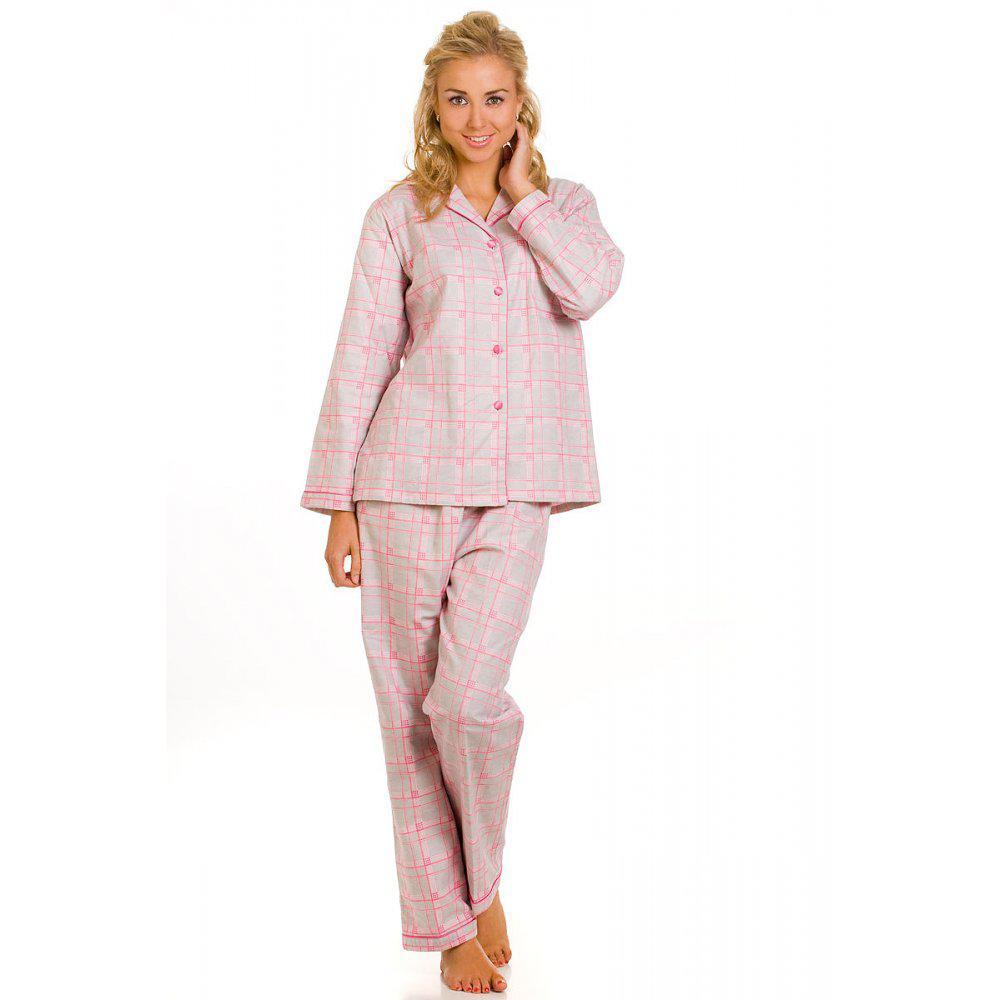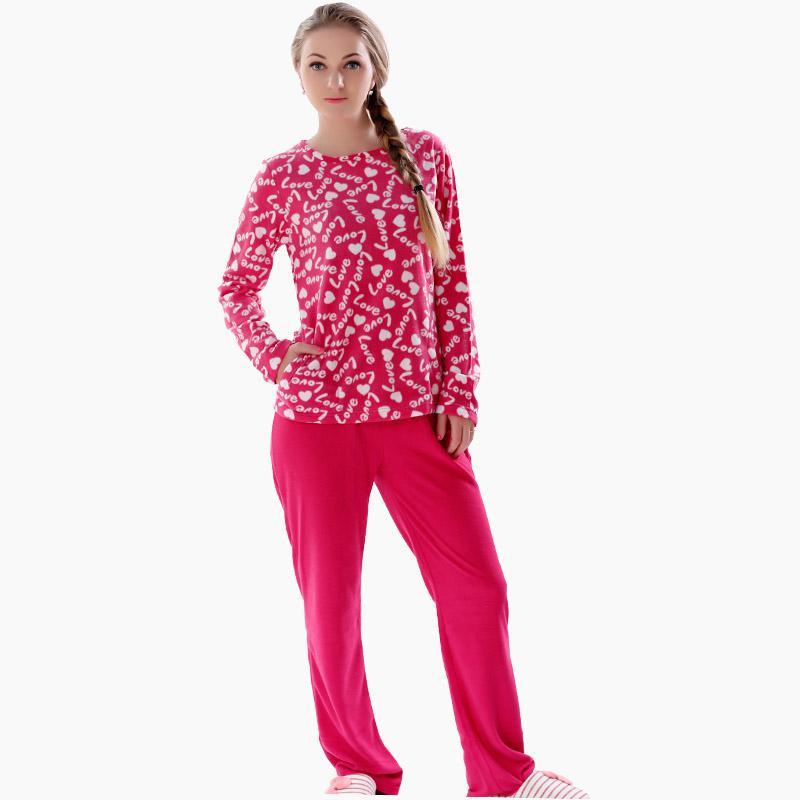The first image is the image on the left, the second image is the image on the right. Assess this claim about the two images: "There are at least four women in the image on the left.". Correct or not? Answer yes or no. No. 